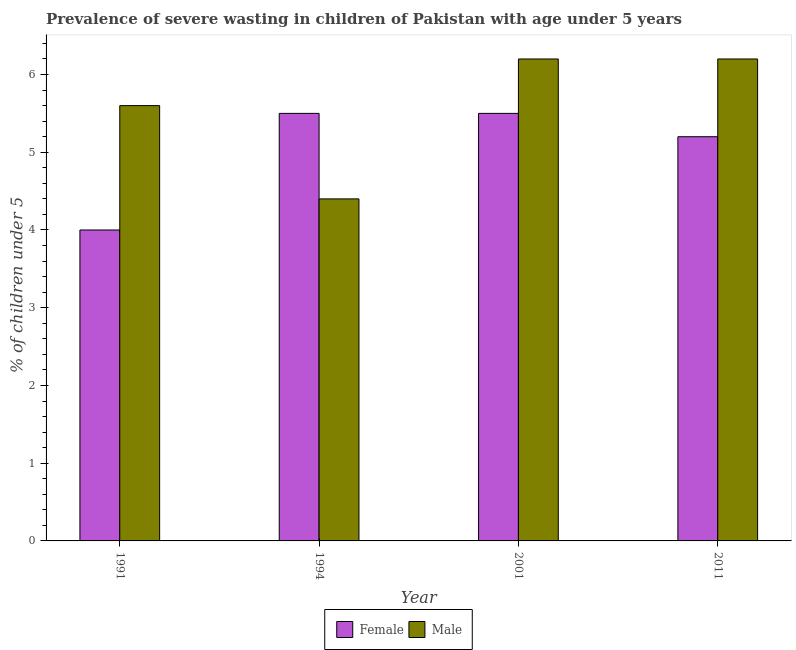How many groups of bars are there?
Your response must be concise. 4. Are the number of bars on each tick of the X-axis equal?
Offer a terse response. Yes. How many bars are there on the 1st tick from the right?
Give a very brief answer. 2. What is the percentage of undernourished female children in 2001?
Provide a short and direct response. 5.5. Across all years, what is the maximum percentage of undernourished female children?
Your response must be concise. 5.5. Across all years, what is the minimum percentage of undernourished male children?
Offer a terse response. 4.4. What is the total percentage of undernourished female children in the graph?
Your response must be concise. 20.2. What is the difference between the percentage of undernourished male children in 1991 and that in 2001?
Make the answer very short. -0.6. What is the difference between the percentage of undernourished male children in 2001 and the percentage of undernourished female children in 1991?
Keep it short and to the point. 0.6. What is the average percentage of undernourished female children per year?
Your answer should be compact. 5.05. What is the ratio of the percentage of undernourished male children in 1994 to that in 2011?
Your answer should be compact. 0.71. Is the percentage of undernourished male children in 1991 less than that in 2011?
Provide a short and direct response. Yes. Is the difference between the percentage of undernourished male children in 1994 and 2001 greater than the difference between the percentage of undernourished female children in 1994 and 2001?
Provide a short and direct response. No. What is the difference between the highest and the second highest percentage of undernourished female children?
Offer a terse response. 0. What is the difference between the highest and the lowest percentage of undernourished female children?
Ensure brevity in your answer.  1.5. In how many years, is the percentage of undernourished male children greater than the average percentage of undernourished male children taken over all years?
Your answer should be very brief. 3. Is the sum of the percentage of undernourished female children in 2001 and 2011 greater than the maximum percentage of undernourished male children across all years?
Keep it short and to the point. Yes. What does the 1st bar from the left in 1991 represents?
Provide a short and direct response. Female. How many years are there in the graph?
Your answer should be very brief. 4. What is the difference between two consecutive major ticks on the Y-axis?
Ensure brevity in your answer.  1. Are the values on the major ticks of Y-axis written in scientific E-notation?
Ensure brevity in your answer.  No. Does the graph contain grids?
Ensure brevity in your answer.  No. Where does the legend appear in the graph?
Your answer should be compact. Bottom center. What is the title of the graph?
Your answer should be very brief. Prevalence of severe wasting in children of Pakistan with age under 5 years. Does "National Tourists" appear as one of the legend labels in the graph?
Keep it short and to the point. No. What is the label or title of the Y-axis?
Offer a very short reply.  % of children under 5. What is the  % of children under 5 of Female in 1991?
Offer a very short reply. 4. What is the  % of children under 5 in Male in 1991?
Offer a very short reply. 5.6. What is the  % of children under 5 of Male in 1994?
Ensure brevity in your answer.  4.4. What is the  % of children under 5 in Male in 2001?
Offer a very short reply. 6.2. What is the  % of children under 5 in Female in 2011?
Provide a succinct answer. 5.2. What is the  % of children under 5 of Male in 2011?
Your answer should be compact. 6.2. Across all years, what is the maximum  % of children under 5 in Male?
Provide a succinct answer. 6.2. Across all years, what is the minimum  % of children under 5 of Male?
Your answer should be very brief. 4.4. What is the total  % of children under 5 in Female in the graph?
Provide a short and direct response. 20.2. What is the total  % of children under 5 in Male in the graph?
Ensure brevity in your answer.  22.4. What is the difference between the  % of children under 5 in Male in 1991 and that in 1994?
Provide a succinct answer. 1.2. What is the difference between the  % of children under 5 of Female in 1991 and that in 2001?
Give a very brief answer. -1.5. What is the difference between the  % of children under 5 of Male in 1991 and that in 2001?
Make the answer very short. -0.6. What is the difference between the  % of children under 5 of Male in 1994 and that in 2011?
Offer a very short reply. -1.8. What is the difference between the  % of children under 5 in Female in 2001 and that in 2011?
Your answer should be compact. 0.3. What is the difference between the  % of children under 5 of Male in 2001 and that in 2011?
Give a very brief answer. 0. What is the difference between the  % of children under 5 in Female in 1991 and the  % of children under 5 in Male in 1994?
Offer a very short reply. -0.4. What is the difference between the  % of children under 5 of Female in 1991 and the  % of children under 5 of Male in 2001?
Your answer should be very brief. -2.2. What is the difference between the  % of children under 5 in Female in 1994 and the  % of children under 5 in Male in 2011?
Give a very brief answer. -0.7. What is the average  % of children under 5 of Female per year?
Keep it short and to the point. 5.05. What is the average  % of children under 5 of Male per year?
Offer a very short reply. 5.6. In the year 1994, what is the difference between the  % of children under 5 of Female and  % of children under 5 of Male?
Your response must be concise. 1.1. In the year 2001, what is the difference between the  % of children under 5 in Female and  % of children under 5 in Male?
Give a very brief answer. -0.7. What is the ratio of the  % of children under 5 in Female in 1991 to that in 1994?
Offer a terse response. 0.73. What is the ratio of the  % of children under 5 in Male in 1991 to that in 1994?
Ensure brevity in your answer.  1.27. What is the ratio of the  % of children under 5 in Female in 1991 to that in 2001?
Your answer should be very brief. 0.73. What is the ratio of the  % of children under 5 of Male in 1991 to that in 2001?
Provide a short and direct response. 0.9. What is the ratio of the  % of children under 5 in Female in 1991 to that in 2011?
Offer a very short reply. 0.77. What is the ratio of the  % of children under 5 of Male in 1991 to that in 2011?
Give a very brief answer. 0.9. What is the ratio of the  % of children under 5 of Male in 1994 to that in 2001?
Offer a terse response. 0.71. What is the ratio of the  % of children under 5 of Female in 1994 to that in 2011?
Your response must be concise. 1.06. What is the ratio of the  % of children under 5 of Male in 1994 to that in 2011?
Ensure brevity in your answer.  0.71. What is the ratio of the  % of children under 5 in Female in 2001 to that in 2011?
Provide a succinct answer. 1.06. What is the difference between the highest and the second highest  % of children under 5 of Female?
Your response must be concise. 0. What is the difference between the highest and the lowest  % of children under 5 of Male?
Your response must be concise. 1.8. 